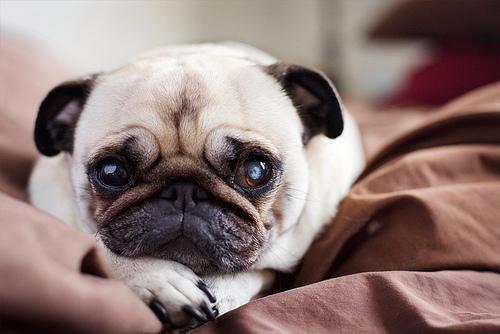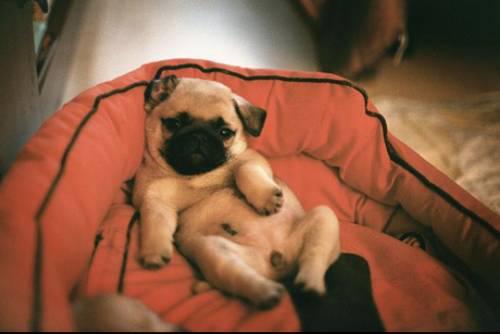The first image is the image on the left, the second image is the image on the right. Evaluate the accuracy of this statement regarding the images: "One of the images has more than one dog.". Is it true? Answer yes or no. No. The first image is the image on the left, the second image is the image on the right. Given the left and right images, does the statement "Each image contains one buff-beige pug with a dark muzzle, and one pug is on an orange cushion while the other is lying flat on its belly." hold true? Answer yes or no. Yes. 